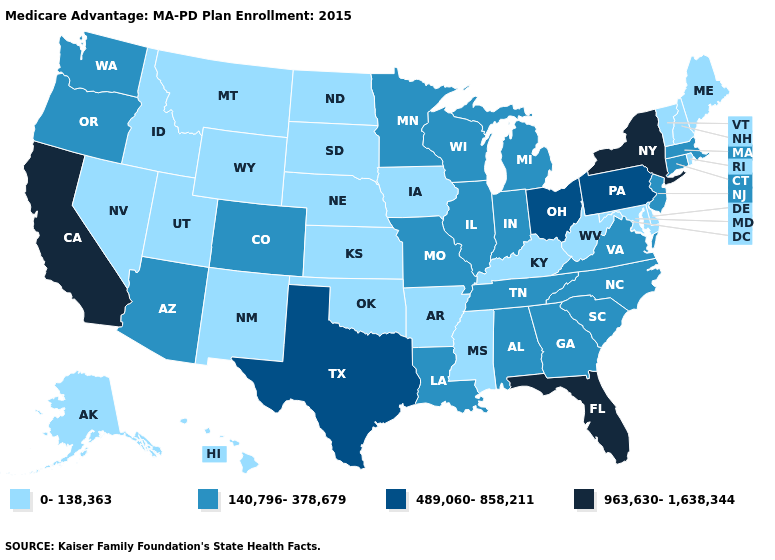Does Wisconsin have the lowest value in the MidWest?
Short answer required. No. Does Florida have the same value as California?
Be succinct. Yes. What is the value of North Dakota?
Write a very short answer. 0-138,363. What is the value of Vermont?
Answer briefly. 0-138,363. Name the states that have a value in the range 140,796-378,679?
Quick response, please. Alabama, Arizona, Colorado, Connecticut, Georgia, Illinois, Indiana, Louisiana, Massachusetts, Michigan, Minnesota, Missouri, North Carolina, New Jersey, Oregon, South Carolina, Tennessee, Virginia, Washington, Wisconsin. Which states hav the highest value in the South?
Keep it brief. Florida. What is the value of Utah?
Be succinct. 0-138,363. Name the states that have a value in the range 963,630-1,638,344?
Write a very short answer. California, Florida, New York. Name the states that have a value in the range 140,796-378,679?
Answer briefly. Alabama, Arizona, Colorado, Connecticut, Georgia, Illinois, Indiana, Louisiana, Massachusetts, Michigan, Minnesota, Missouri, North Carolina, New Jersey, Oregon, South Carolina, Tennessee, Virginia, Washington, Wisconsin. Does Indiana have the lowest value in the MidWest?
Concise answer only. No. Does Kansas have the highest value in the MidWest?
Be succinct. No. Does Florida have the highest value in the USA?
Give a very brief answer. Yes. What is the lowest value in states that border West Virginia?
Short answer required. 0-138,363. Does the first symbol in the legend represent the smallest category?
Write a very short answer. Yes. How many symbols are there in the legend?
Write a very short answer. 4. 